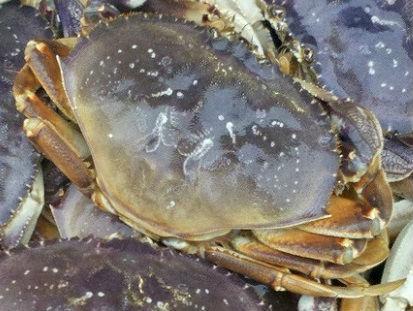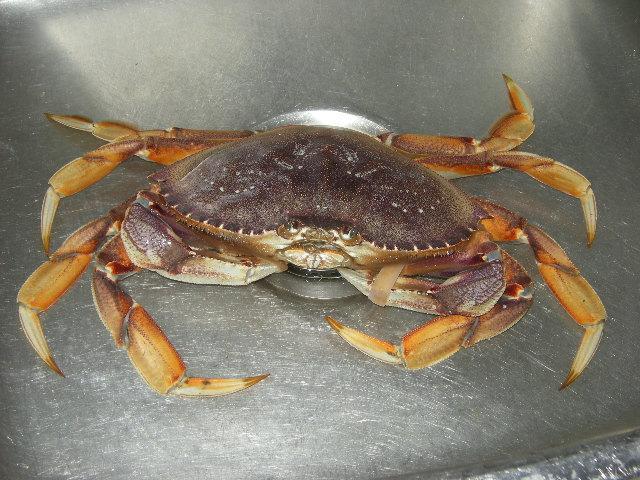The first image is the image on the left, the second image is the image on the right. For the images displayed, is the sentence "Two hands are holding the crab in the left image." factually correct? Answer yes or no. No. The first image is the image on the left, the second image is the image on the right. Examine the images to the left and right. Is the description "A person is touching the crab in the image on the left." accurate? Answer yes or no. No. 